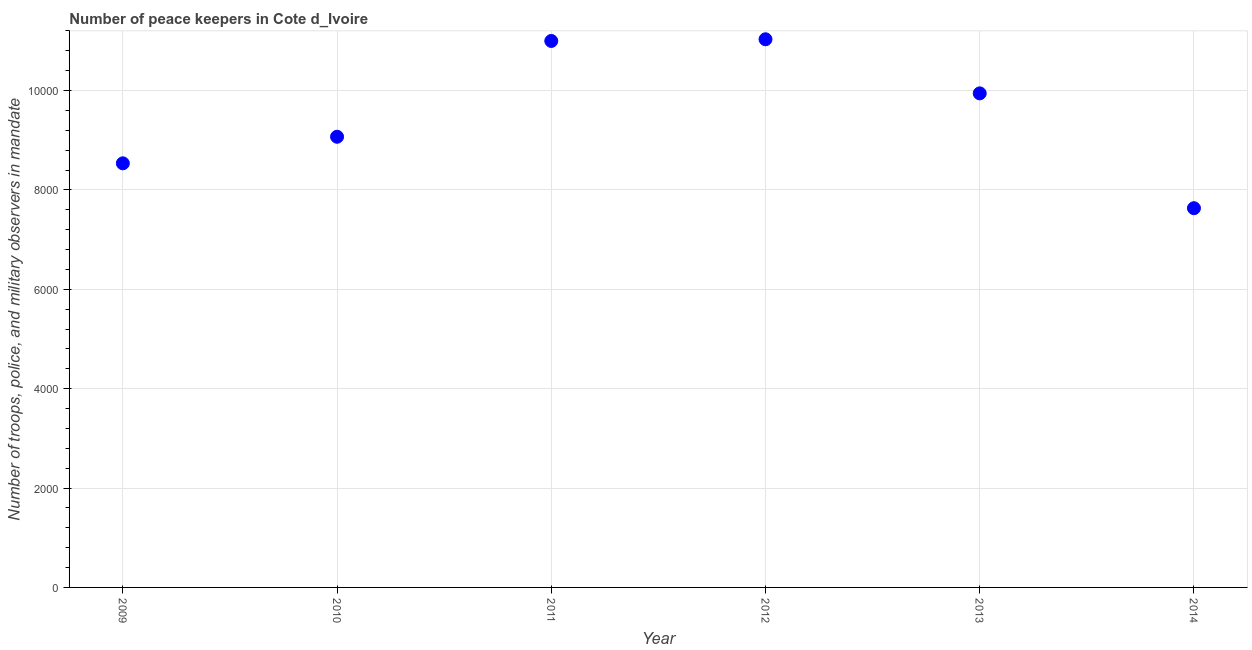What is the number of peace keepers in 2013?
Give a very brief answer. 9944. Across all years, what is the maximum number of peace keepers?
Make the answer very short. 1.10e+04. Across all years, what is the minimum number of peace keepers?
Make the answer very short. 7633. In which year was the number of peace keepers maximum?
Keep it short and to the point. 2012. What is the sum of the number of peace keepers?
Offer a terse response. 5.72e+04. What is the difference between the number of peace keepers in 2009 and 2013?
Ensure brevity in your answer.  -1408. What is the average number of peace keepers per year?
Keep it short and to the point. 9536. What is the median number of peace keepers?
Offer a very short reply. 9507.5. In how many years, is the number of peace keepers greater than 3600 ?
Ensure brevity in your answer.  6. What is the ratio of the number of peace keepers in 2010 to that in 2013?
Offer a very short reply. 0.91. Is the number of peace keepers in 2011 less than that in 2014?
Offer a very short reply. No. Is the difference between the number of peace keepers in 2009 and 2012 greater than the difference between any two years?
Keep it short and to the point. No. What is the difference between the highest and the lowest number of peace keepers?
Your answer should be very brief. 3400. In how many years, is the number of peace keepers greater than the average number of peace keepers taken over all years?
Your answer should be compact. 3. How many dotlines are there?
Make the answer very short. 1. What is the difference between two consecutive major ticks on the Y-axis?
Your answer should be compact. 2000. Are the values on the major ticks of Y-axis written in scientific E-notation?
Offer a terse response. No. Does the graph contain grids?
Your answer should be very brief. Yes. What is the title of the graph?
Your answer should be compact. Number of peace keepers in Cote d_Ivoire. What is the label or title of the Y-axis?
Your response must be concise. Number of troops, police, and military observers in mandate. What is the Number of troops, police, and military observers in mandate in 2009?
Your answer should be very brief. 8536. What is the Number of troops, police, and military observers in mandate in 2010?
Offer a very short reply. 9071. What is the Number of troops, police, and military observers in mandate in 2011?
Your answer should be very brief. 1.10e+04. What is the Number of troops, police, and military observers in mandate in 2012?
Give a very brief answer. 1.10e+04. What is the Number of troops, police, and military observers in mandate in 2013?
Ensure brevity in your answer.  9944. What is the Number of troops, police, and military observers in mandate in 2014?
Offer a terse response. 7633. What is the difference between the Number of troops, police, and military observers in mandate in 2009 and 2010?
Ensure brevity in your answer.  -535. What is the difference between the Number of troops, police, and military observers in mandate in 2009 and 2011?
Make the answer very short. -2463. What is the difference between the Number of troops, police, and military observers in mandate in 2009 and 2012?
Keep it short and to the point. -2497. What is the difference between the Number of troops, police, and military observers in mandate in 2009 and 2013?
Ensure brevity in your answer.  -1408. What is the difference between the Number of troops, police, and military observers in mandate in 2009 and 2014?
Provide a short and direct response. 903. What is the difference between the Number of troops, police, and military observers in mandate in 2010 and 2011?
Keep it short and to the point. -1928. What is the difference between the Number of troops, police, and military observers in mandate in 2010 and 2012?
Your response must be concise. -1962. What is the difference between the Number of troops, police, and military observers in mandate in 2010 and 2013?
Offer a very short reply. -873. What is the difference between the Number of troops, police, and military observers in mandate in 2010 and 2014?
Your answer should be compact. 1438. What is the difference between the Number of troops, police, and military observers in mandate in 2011 and 2012?
Provide a short and direct response. -34. What is the difference between the Number of troops, police, and military observers in mandate in 2011 and 2013?
Your response must be concise. 1055. What is the difference between the Number of troops, police, and military observers in mandate in 2011 and 2014?
Provide a succinct answer. 3366. What is the difference between the Number of troops, police, and military observers in mandate in 2012 and 2013?
Your response must be concise. 1089. What is the difference between the Number of troops, police, and military observers in mandate in 2012 and 2014?
Give a very brief answer. 3400. What is the difference between the Number of troops, police, and military observers in mandate in 2013 and 2014?
Make the answer very short. 2311. What is the ratio of the Number of troops, police, and military observers in mandate in 2009 to that in 2010?
Provide a short and direct response. 0.94. What is the ratio of the Number of troops, police, and military observers in mandate in 2009 to that in 2011?
Your response must be concise. 0.78. What is the ratio of the Number of troops, police, and military observers in mandate in 2009 to that in 2012?
Your answer should be compact. 0.77. What is the ratio of the Number of troops, police, and military observers in mandate in 2009 to that in 2013?
Make the answer very short. 0.86. What is the ratio of the Number of troops, police, and military observers in mandate in 2009 to that in 2014?
Offer a terse response. 1.12. What is the ratio of the Number of troops, police, and military observers in mandate in 2010 to that in 2011?
Ensure brevity in your answer.  0.82. What is the ratio of the Number of troops, police, and military observers in mandate in 2010 to that in 2012?
Your answer should be very brief. 0.82. What is the ratio of the Number of troops, police, and military observers in mandate in 2010 to that in 2013?
Ensure brevity in your answer.  0.91. What is the ratio of the Number of troops, police, and military observers in mandate in 2010 to that in 2014?
Ensure brevity in your answer.  1.19. What is the ratio of the Number of troops, police, and military observers in mandate in 2011 to that in 2013?
Provide a short and direct response. 1.11. What is the ratio of the Number of troops, police, and military observers in mandate in 2011 to that in 2014?
Make the answer very short. 1.44. What is the ratio of the Number of troops, police, and military observers in mandate in 2012 to that in 2013?
Your response must be concise. 1.11. What is the ratio of the Number of troops, police, and military observers in mandate in 2012 to that in 2014?
Your response must be concise. 1.45. What is the ratio of the Number of troops, police, and military observers in mandate in 2013 to that in 2014?
Keep it short and to the point. 1.3. 